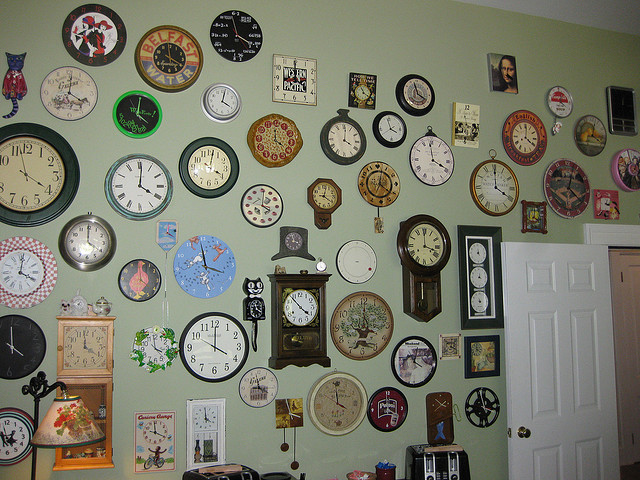What country is represented by the top row of clocks? The clocks do not clearly represent any specific country, as there's no visible text or flag indicative of a particular nation. 